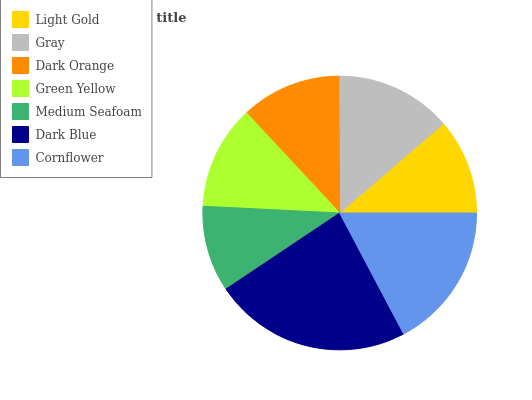Is Medium Seafoam the minimum?
Answer yes or no. Yes. Is Dark Blue the maximum?
Answer yes or no. Yes. Is Gray the minimum?
Answer yes or no. No. Is Gray the maximum?
Answer yes or no. No. Is Gray greater than Light Gold?
Answer yes or no. Yes. Is Light Gold less than Gray?
Answer yes or no. Yes. Is Light Gold greater than Gray?
Answer yes or no. No. Is Gray less than Light Gold?
Answer yes or no. No. Is Green Yellow the high median?
Answer yes or no. Yes. Is Green Yellow the low median?
Answer yes or no. Yes. Is Medium Seafoam the high median?
Answer yes or no. No. Is Gray the low median?
Answer yes or no. No. 